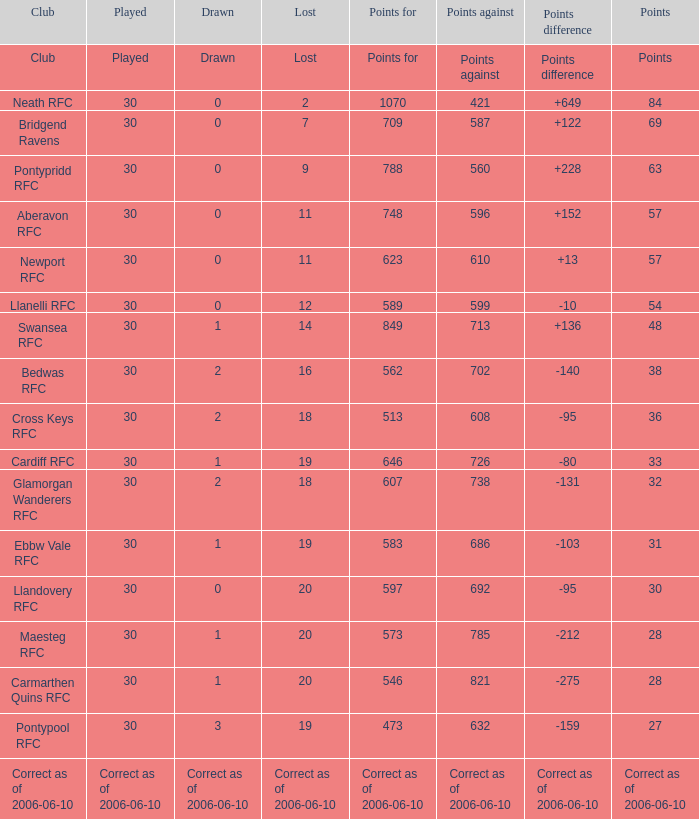Could you parse the entire table as a dict? {'header': ['Club', 'Played', 'Drawn', 'Lost', 'Points for', 'Points against', 'Points difference', 'Points'], 'rows': [['Club', 'Played', 'Drawn', 'Lost', 'Points for', 'Points against', 'Points difference', 'Points'], ['Neath RFC', '30', '0', '2', '1070', '421', '+649', '84'], ['Bridgend Ravens', '30', '0', '7', '709', '587', '+122', '69'], ['Pontypridd RFC', '30', '0', '9', '788', '560', '+228', '63'], ['Aberavon RFC', '30', '0', '11', '748', '596', '+152', '57'], ['Newport RFC', '30', '0', '11', '623', '610', '+13', '57'], ['Llanelli RFC', '30', '0', '12', '589', '599', '-10', '54'], ['Swansea RFC', '30', '1', '14', '849', '713', '+136', '48'], ['Bedwas RFC', '30', '2', '16', '562', '702', '-140', '38'], ['Cross Keys RFC', '30', '2', '18', '513', '608', '-95', '36'], ['Cardiff RFC', '30', '1', '19', '646', '726', '-80', '33'], ['Glamorgan Wanderers RFC', '30', '2', '18', '607', '738', '-131', '32'], ['Ebbw Vale RFC', '30', '1', '19', '583', '686', '-103', '31'], ['Llandovery RFC', '30', '0', '20', '597', '692', '-95', '30'], ['Maesteg RFC', '30', '1', '20', '573', '785', '-212', '28'], ['Carmarthen Quins RFC', '30', '1', '20', '546', '821', '-275', '28'], ['Pontypool RFC', '30', '3', '19', '473', '632', '-159', '27'], ['Correct as of 2006-06-10', 'Correct as of 2006-06-10', 'Correct as of 2006-06-10', 'Correct as of 2006-06-10', 'Correct as of 2006-06-10', 'Correct as of 2006-06-10', 'Correct as of 2006-06-10', 'Correct as of 2006-06-10']]} When drawn is "2" and points is "36", what is the value of lost? 18.0. 